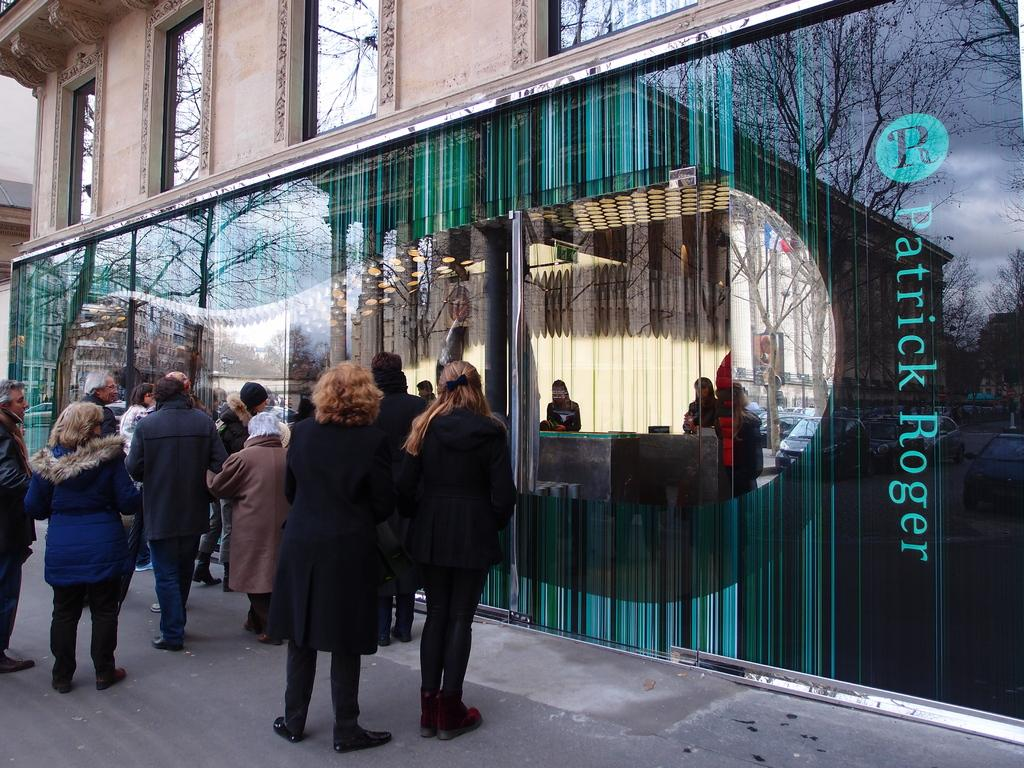What is the main structure visible in the image? There is a building in the image. What feature can be seen on the building? The building has windows. Is there any writing or text on the building? Yes, there is text written on the building. What else can be seen in the image besides the building? There are people standing on the road in the image. What type of needle is being used for punishment in the image? There is no needle or punishment present in the image; it features a building with windows and text, along with people standing on the road. 